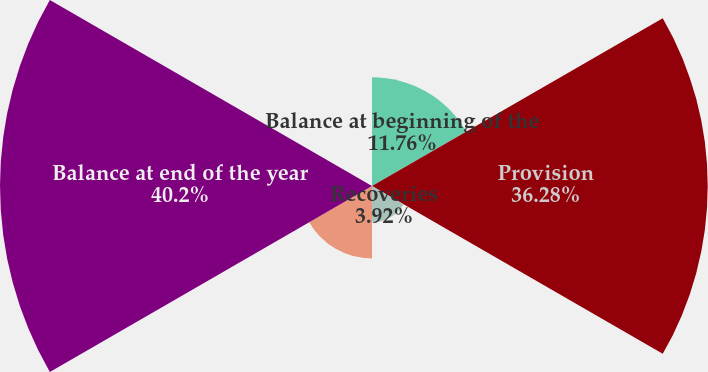Convert chart to OTSL. <chart><loc_0><loc_0><loc_500><loc_500><pie_chart><fcel>Balance at beginning of the<fcel>Provision<fcel>Recoveries<fcel>Charge-offs and transfers<fcel>Balance at end of the year<fcel>Ratio of net charge-offs to<nl><fcel>11.76%<fcel>36.28%<fcel>3.92%<fcel>7.84%<fcel>40.2%<fcel>0.0%<nl></chart> 